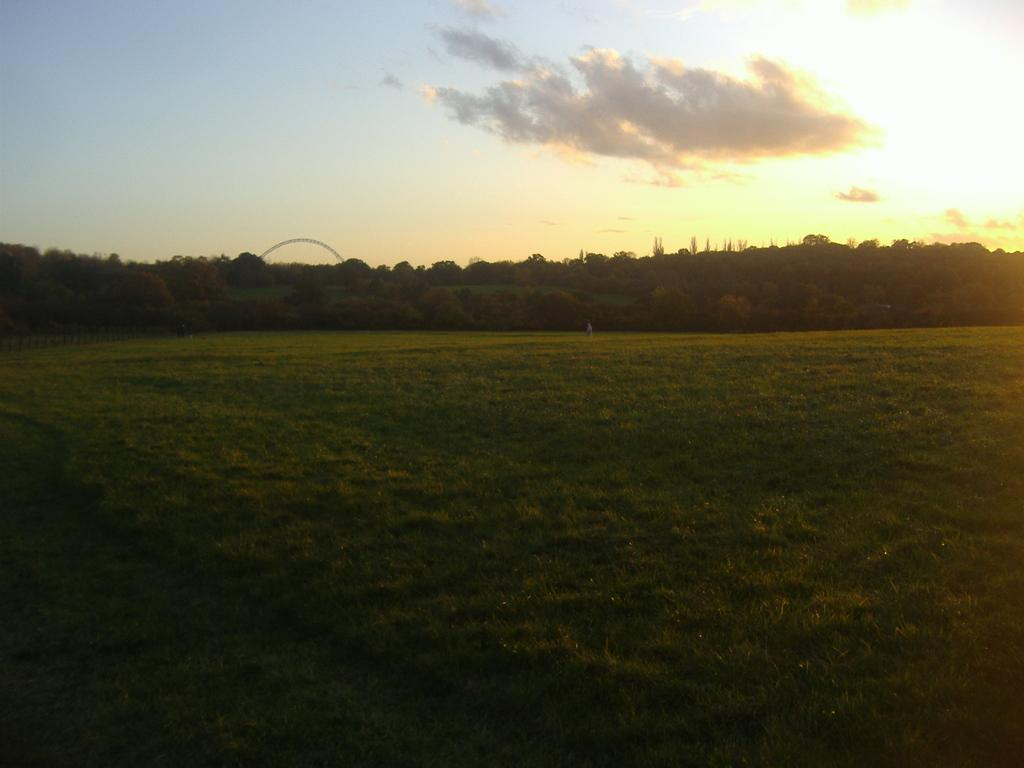What type of vegetation can be seen in the image? There are trees on the grassland in the image. What is visible at the top of the image? The sky is visible at the top of the image. What can be observed in the sky? There are clouds in the sky. Is there a cup floating in the river in the image? There is no river or cup present in the image. How does the digestion process of the trees affect the grassland in the image? The image does not depict any trees undergoing a digestion process, nor does it show any impact on the grassland. 